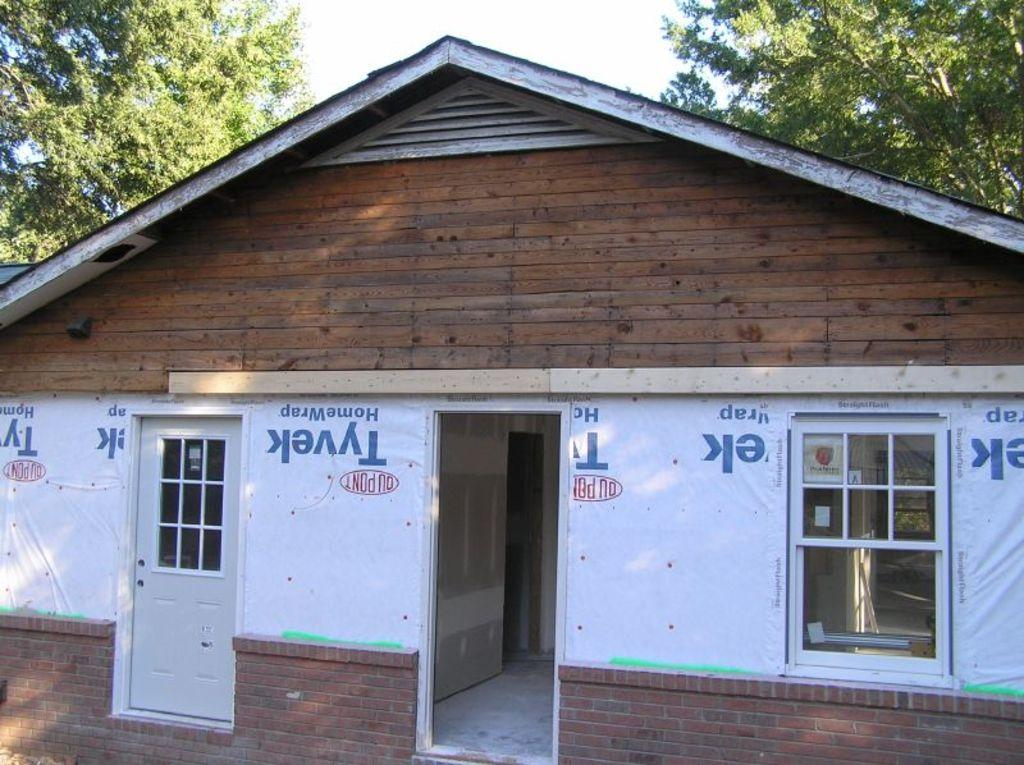What type of house is in the image? There is a wooden house in the image. What features can be seen on the house? The house has doors and windows. What is located on either side of the house in the image? There are trees on either side of the house in the image. What is visible at the top of the image? The sky is visible at the top of the image. What type of dinner is being served on the sidewalk in the image? There is no sidewalk or dinner present in the image; it features a wooden house with trees on either side and a visible sky. Can you see a pig in the image? No, there is no pig present in the image. 